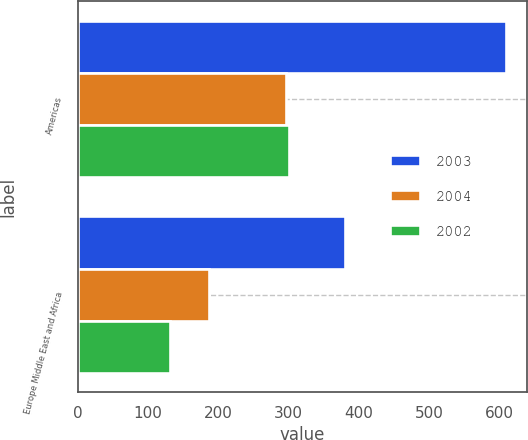Convert chart to OTSL. <chart><loc_0><loc_0><loc_500><loc_500><stacked_bar_chart><ecel><fcel>Americas<fcel>Europe Middle East and Africa<nl><fcel>2003<fcel>609.1<fcel>380.5<nl><fcel>2004<fcel>296.2<fcel>186.4<nl><fcel>2002<fcel>300<fcel>131.1<nl></chart> 